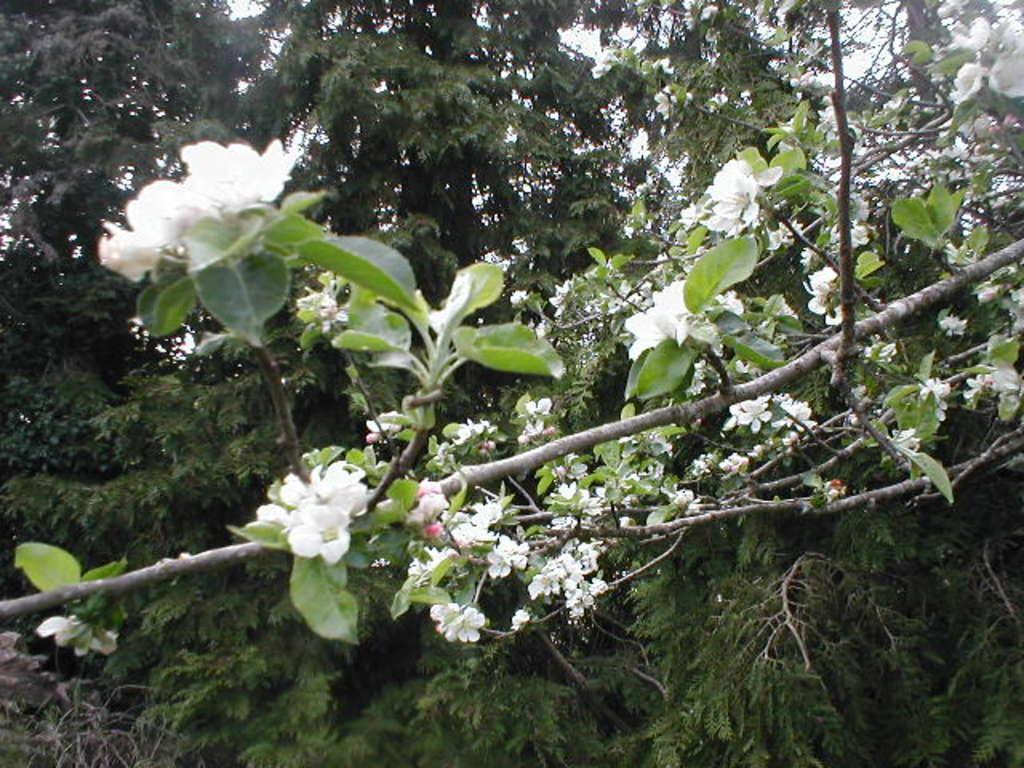Can you describe this image briefly? In this image I can see number of trees and here I can see white colour flowers. 